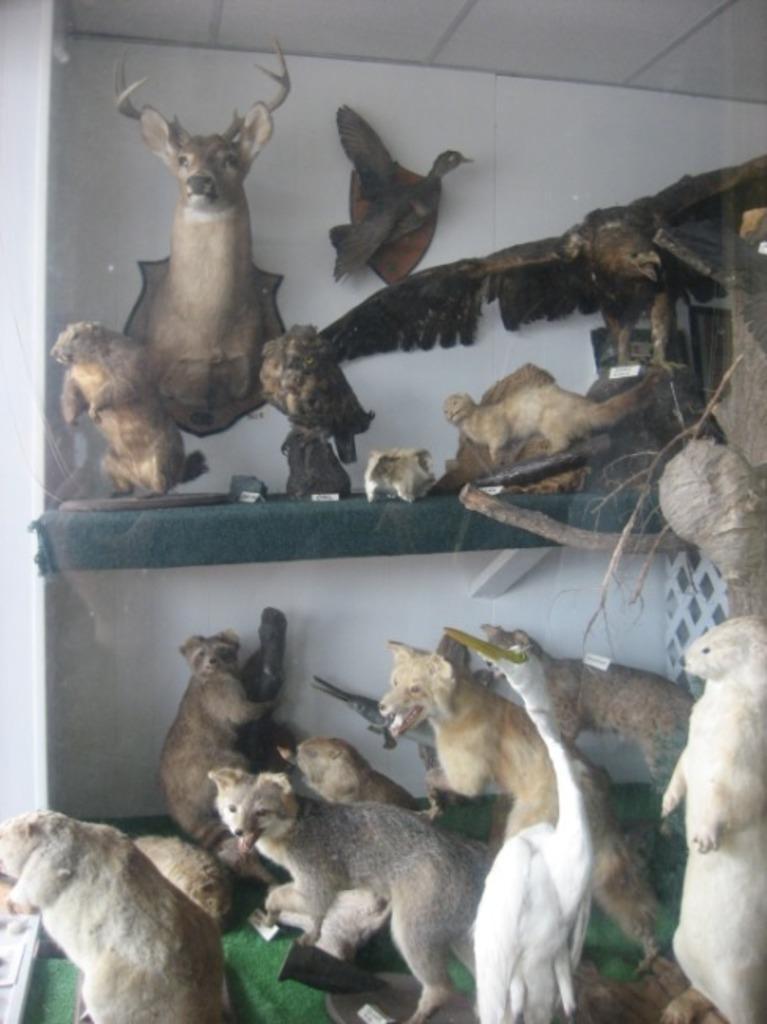Describe this image in one or two sentences. In the picture there are many toys of different animals, in the background there is a wall. 